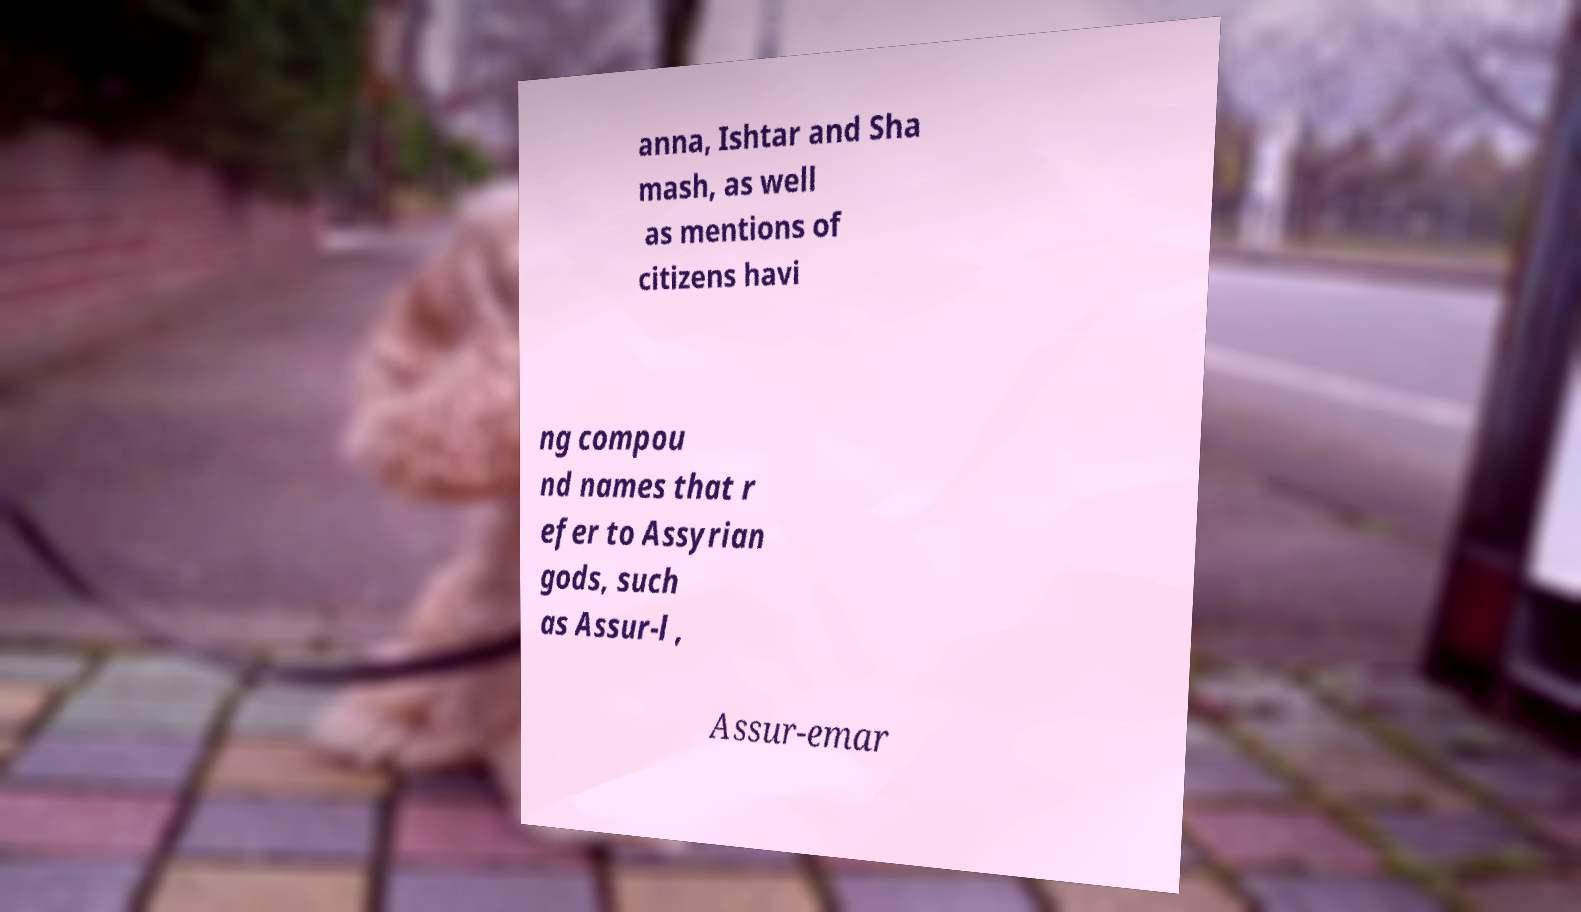Can you accurately transcribe the text from the provided image for me? anna, Ishtar and Sha mash, as well as mentions of citizens havi ng compou nd names that r efer to Assyrian gods, such as Assur-l , Assur-emar 